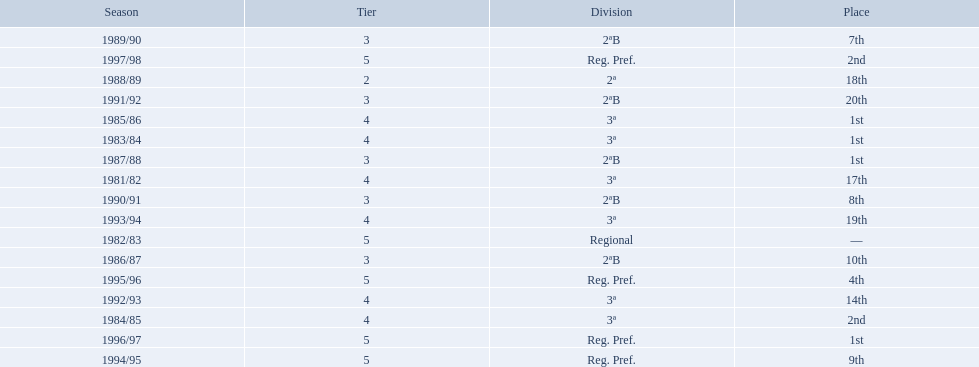In what years did the team finish 17th or worse? 1981/82, 1988/89, 1991/92, 1993/94. Of those, in which year the team finish worse? 1991/92. 